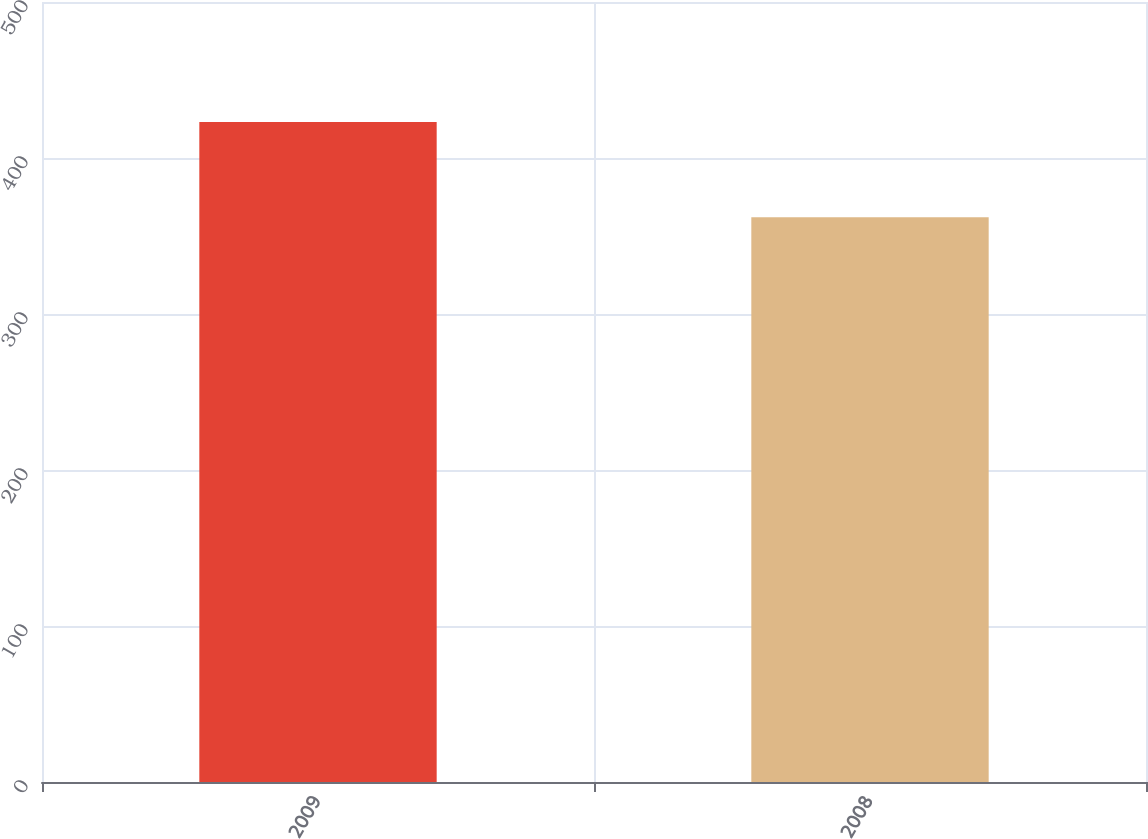<chart> <loc_0><loc_0><loc_500><loc_500><bar_chart><fcel>2009<fcel>2008<nl><fcel>423<fcel>362<nl></chart> 